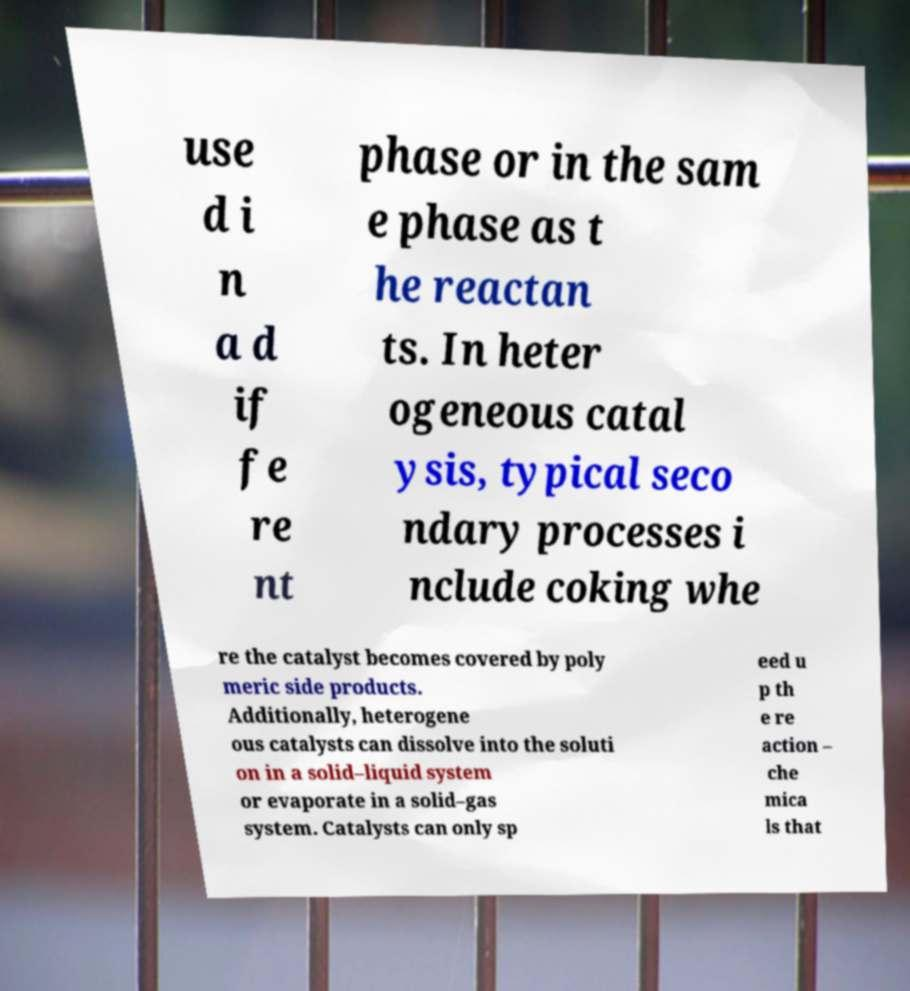There's text embedded in this image that I need extracted. Can you transcribe it verbatim? use d i n a d if fe re nt phase or in the sam e phase as t he reactan ts. In heter ogeneous catal ysis, typical seco ndary processes i nclude coking whe re the catalyst becomes covered by poly meric side products. Additionally, heterogene ous catalysts can dissolve into the soluti on in a solid–liquid system or evaporate in a solid–gas system. Catalysts can only sp eed u p th e re action – che mica ls that 